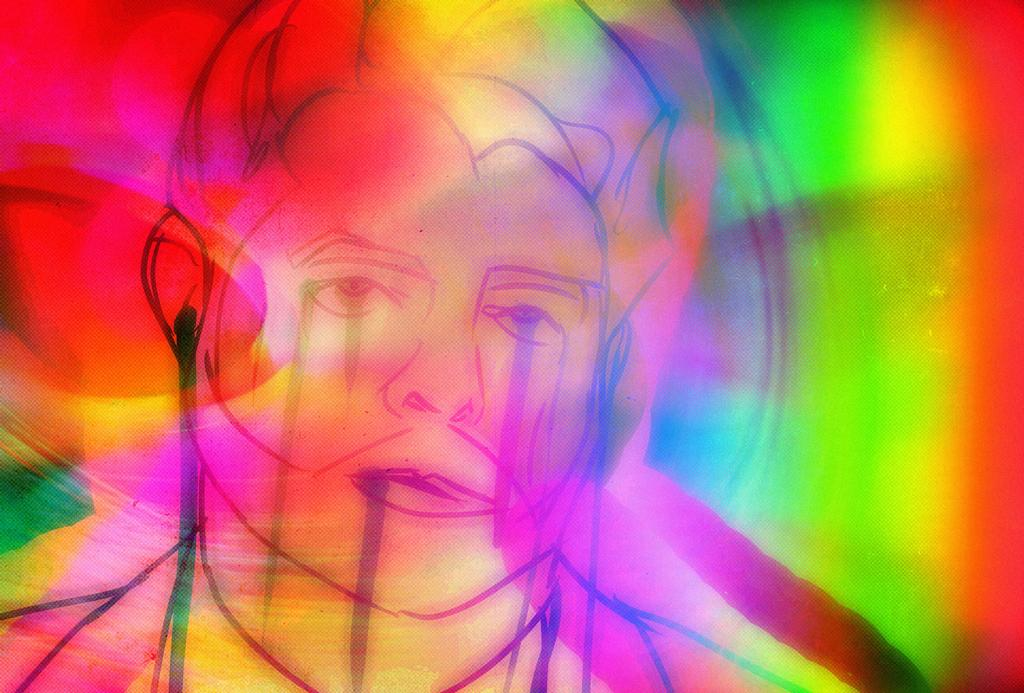What type of image is being described? The image is an art piece. Can you describe the subject of the art? There is a person depicted in the art. What can be said about the color scheme of the art? Multiple colors are present in the art. What type of pest can be seen in the art? There is no pest present in the art; it depicts a person. What shape is the art piece? The shape of the art piece is not mentioned in the provided facts, so it cannot be determined. 